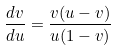<formula> <loc_0><loc_0><loc_500><loc_500>\frac { d v } { d u } = \frac { v ( u - v ) } { u ( 1 - v ) }</formula> 